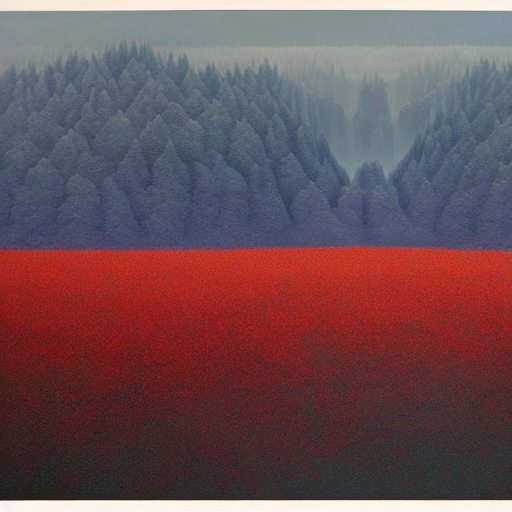Is there no loss of any texture information in the image? Option A, no loss of texture, suggests that all fine details are preserved. However, upon closer examination, although the image retains a significant amount of texture detail, there might be some areas where finer details are not as crisp due to resolution, compression, or focus. Therefore, an absolute assertion that there's no loss may not be accurate for every part of the image. 